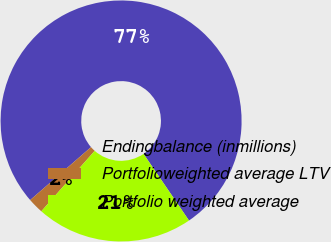Convert chart to OTSL. <chart><loc_0><loc_0><loc_500><loc_500><pie_chart><fcel>Endingbalance (inmillions)<fcel>Portfolioweighted average LTV<fcel>Portfolio weighted average<nl><fcel>76.87%<fcel>2.09%<fcel>21.04%<nl></chart> 